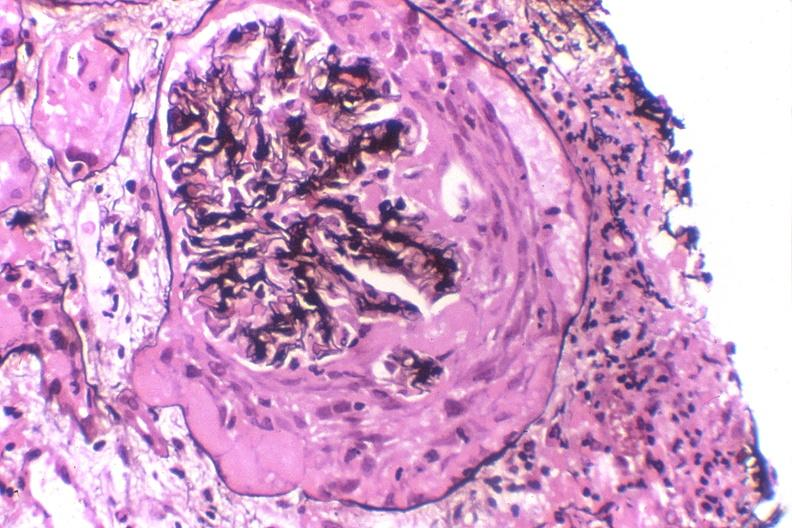does odontoid process subluxation with narrowing of foramen magnum show crescentric glomerulonephritis?
Answer the question using a single word or phrase. No 